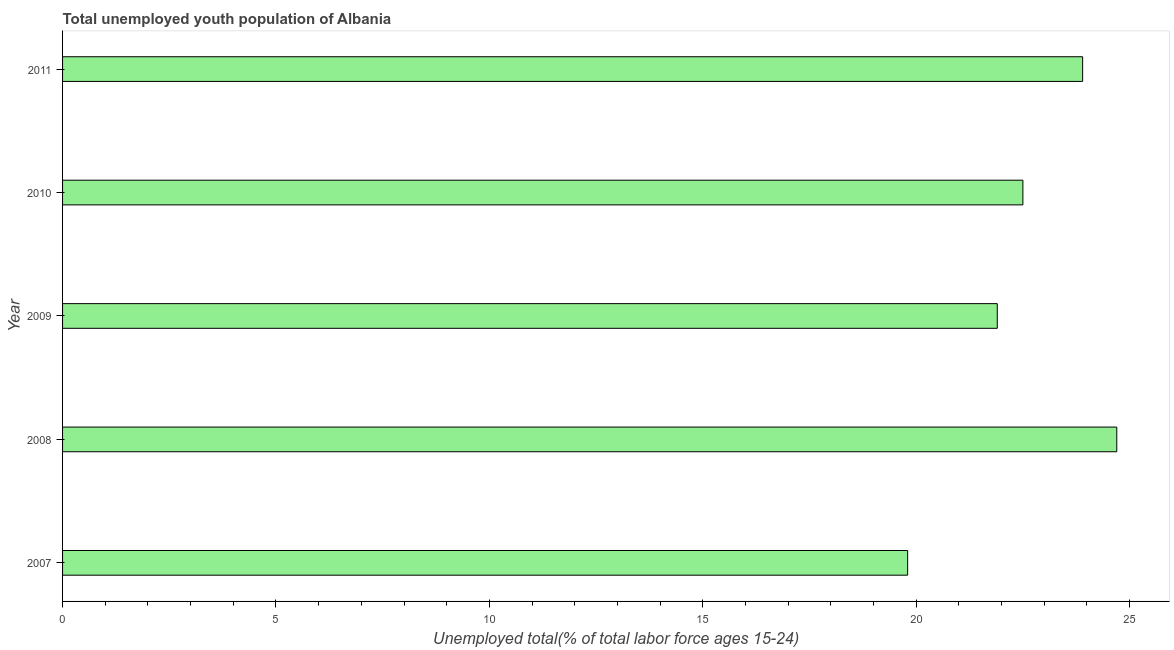Does the graph contain any zero values?
Make the answer very short. No. Does the graph contain grids?
Offer a terse response. No. What is the title of the graph?
Your response must be concise. Total unemployed youth population of Albania. What is the label or title of the X-axis?
Keep it short and to the point. Unemployed total(% of total labor force ages 15-24). What is the label or title of the Y-axis?
Keep it short and to the point. Year. What is the unemployed youth in 2008?
Ensure brevity in your answer.  24.7. Across all years, what is the maximum unemployed youth?
Keep it short and to the point. 24.7. Across all years, what is the minimum unemployed youth?
Make the answer very short. 19.8. In which year was the unemployed youth maximum?
Give a very brief answer. 2008. What is the sum of the unemployed youth?
Your answer should be very brief. 112.8. What is the average unemployed youth per year?
Keep it short and to the point. 22.56. What is the median unemployed youth?
Your answer should be very brief. 22.5. In how many years, is the unemployed youth greater than 4 %?
Offer a very short reply. 5. What is the ratio of the unemployed youth in 2008 to that in 2010?
Offer a terse response. 1.1. How many bars are there?
Provide a succinct answer. 5. How many years are there in the graph?
Ensure brevity in your answer.  5. What is the Unemployed total(% of total labor force ages 15-24) of 2007?
Your answer should be very brief. 19.8. What is the Unemployed total(% of total labor force ages 15-24) in 2008?
Your response must be concise. 24.7. What is the Unemployed total(% of total labor force ages 15-24) in 2009?
Give a very brief answer. 21.9. What is the Unemployed total(% of total labor force ages 15-24) in 2011?
Make the answer very short. 23.9. What is the difference between the Unemployed total(% of total labor force ages 15-24) in 2007 and 2008?
Ensure brevity in your answer.  -4.9. What is the difference between the Unemployed total(% of total labor force ages 15-24) in 2008 and 2010?
Your answer should be very brief. 2.2. What is the difference between the Unemployed total(% of total labor force ages 15-24) in 2009 and 2011?
Make the answer very short. -2. What is the ratio of the Unemployed total(% of total labor force ages 15-24) in 2007 to that in 2008?
Provide a succinct answer. 0.8. What is the ratio of the Unemployed total(% of total labor force ages 15-24) in 2007 to that in 2009?
Your answer should be very brief. 0.9. What is the ratio of the Unemployed total(% of total labor force ages 15-24) in 2007 to that in 2011?
Keep it short and to the point. 0.83. What is the ratio of the Unemployed total(% of total labor force ages 15-24) in 2008 to that in 2009?
Your answer should be very brief. 1.13. What is the ratio of the Unemployed total(% of total labor force ages 15-24) in 2008 to that in 2010?
Provide a succinct answer. 1.1. What is the ratio of the Unemployed total(% of total labor force ages 15-24) in 2008 to that in 2011?
Give a very brief answer. 1.03. What is the ratio of the Unemployed total(% of total labor force ages 15-24) in 2009 to that in 2010?
Your answer should be very brief. 0.97. What is the ratio of the Unemployed total(% of total labor force ages 15-24) in 2009 to that in 2011?
Give a very brief answer. 0.92. What is the ratio of the Unemployed total(% of total labor force ages 15-24) in 2010 to that in 2011?
Your answer should be compact. 0.94. 